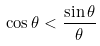Convert formula to latex. <formula><loc_0><loc_0><loc_500><loc_500>\cos \theta < { \frac { \sin \theta } { \theta } }</formula> 